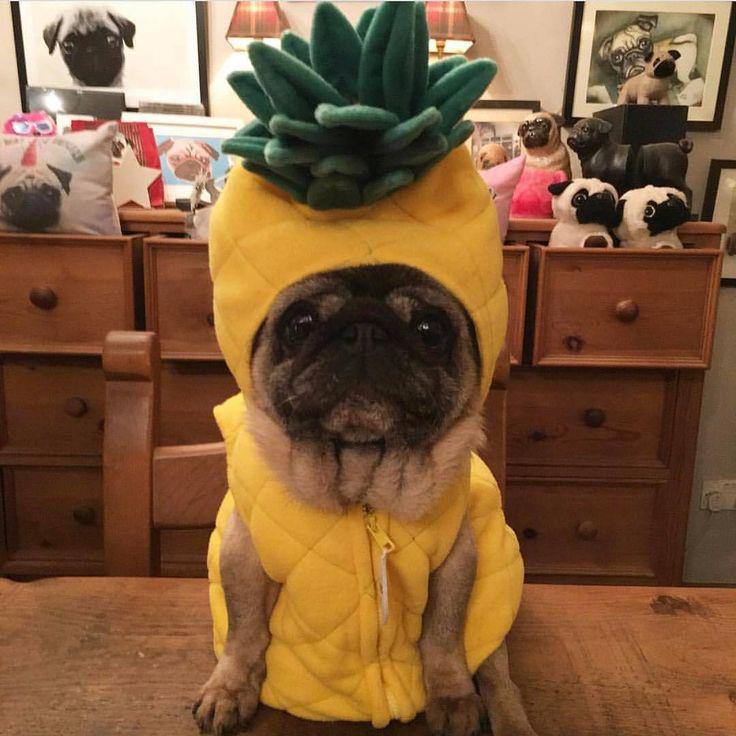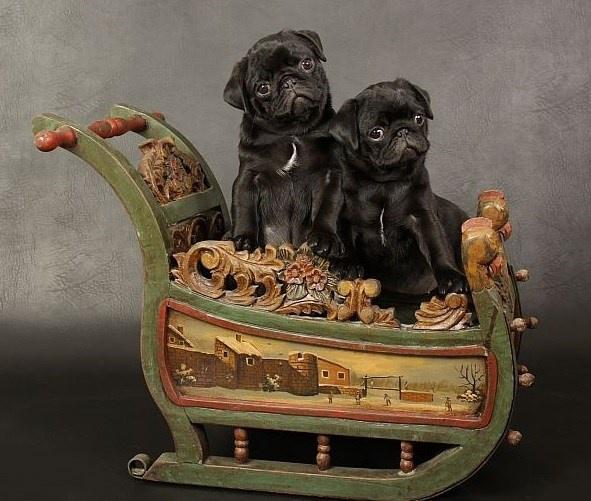The first image is the image on the left, the second image is the image on the right. For the images displayed, is the sentence "An image shows exactly one living pug that is sitting." factually correct? Answer yes or no. Yes. 